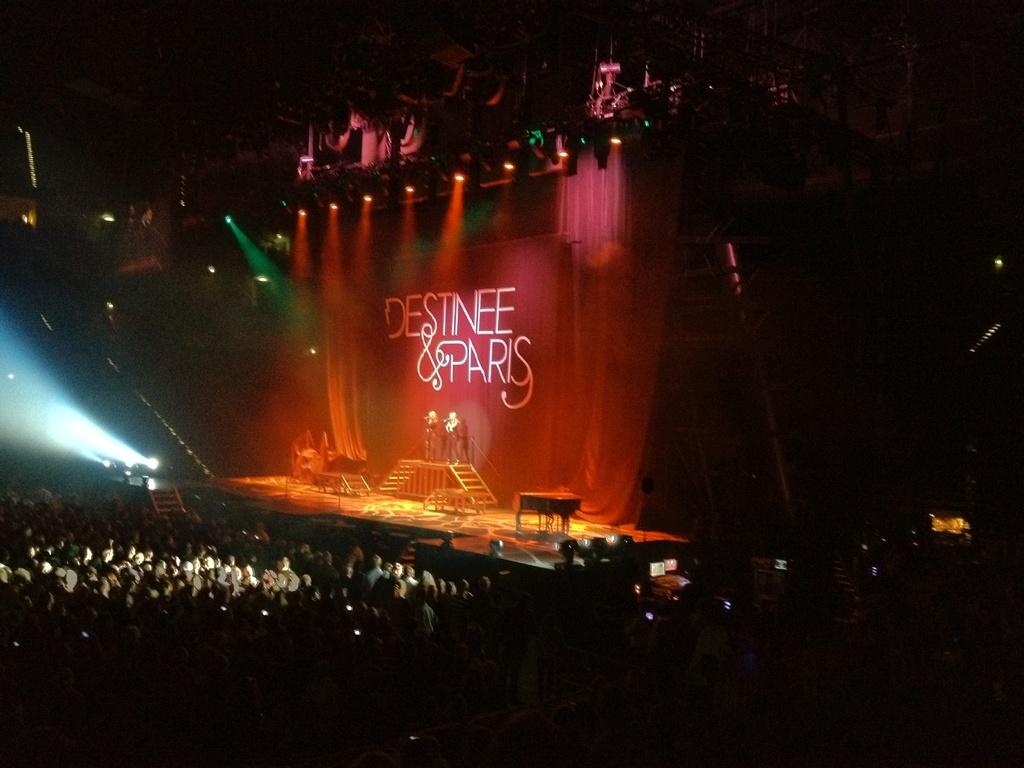How many people are in the image? There is a group of people in the image, but the exact number is not specified. Where are some of the people located in the image? Some people are on a stage in the image. What can be seen illuminating the scene in the image? There are lights visible in the image. What is present on the wall in the image? There is a poster in the image. What architectural feature is present in the image? There are steps in the image. What else is visible in the image besides the people and the stage? There are objects in the image. How would you describe the lighting conditions in the image? The background of the image is dark. What type of wind can be seen blowing through the image? There is no wind present in the image; it is not mentioned in the provided facts. Are there any clouds visible in the image? The provided facts do not mention any clouds in the image. Is there any snow falling in the image? There is no mention of snow in the provided facts, so it cannot be determined from the image. 